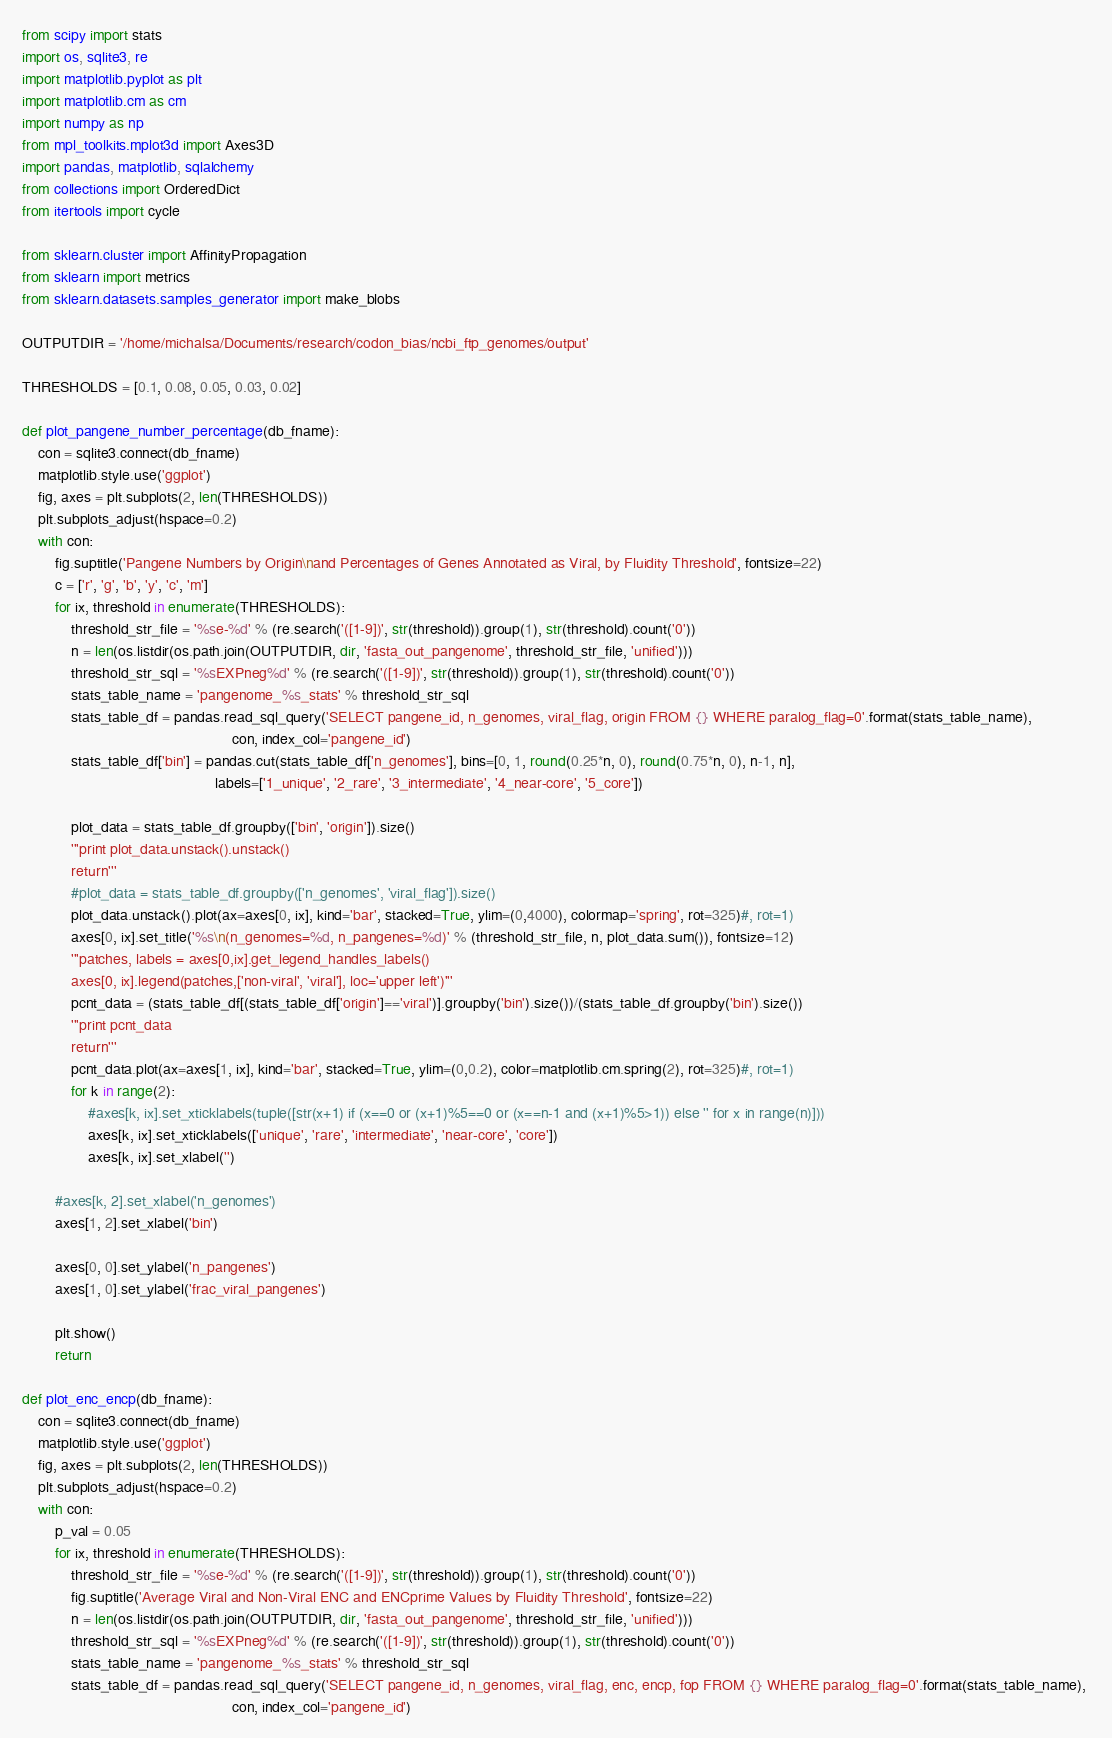Convert code to text. <code><loc_0><loc_0><loc_500><loc_500><_Python_>from scipy import stats
import os, sqlite3, re
import matplotlib.pyplot as plt
import matplotlib.cm as cm
import numpy as np
from mpl_toolkits.mplot3d import Axes3D
import pandas, matplotlib, sqlalchemy
from collections import OrderedDict
from itertools import cycle

from sklearn.cluster import AffinityPropagation
from sklearn import metrics
from sklearn.datasets.samples_generator import make_blobs

OUTPUTDIR = '/home/michalsa/Documents/research/codon_bias/ncbi_ftp_genomes/output'

THRESHOLDS = [0.1, 0.08, 0.05, 0.03, 0.02]

def plot_pangene_number_percentage(db_fname):
    con = sqlite3.connect(db_fname)
    matplotlib.style.use('ggplot')
    fig, axes = plt.subplots(2, len(THRESHOLDS))
    plt.subplots_adjust(hspace=0.2)
    with con:        
        fig.suptitle('Pangene Numbers by Origin\nand Percentages of Genes Annotated as Viral, by Fluidity Threshold', fontsize=22)
        c = ['r', 'g', 'b', 'y', 'c', 'm']
        for ix, threshold in enumerate(THRESHOLDS):
            threshold_str_file = '%se-%d' % (re.search('([1-9])', str(threshold)).group(1), str(threshold).count('0'))
            n = len(os.listdir(os.path.join(OUTPUTDIR, dir, 'fasta_out_pangenome', threshold_str_file, 'unified')))
            threshold_str_sql = '%sEXPneg%d' % (re.search('([1-9])', str(threshold)).group(1), str(threshold).count('0'))
            stats_table_name = 'pangenome_%s_stats' % threshold_str_sql
            stats_table_df = pandas.read_sql_query('SELECT pangene_id, n_genomes, viral_flag, origin FROM {} WHERE paralog_flag=0'.format(stats_table_name), 
                                                   con, index_col='pangene_id')
            stats_table_df['bin'] = pandas.cut(stats_table_df['n_genomes'], bins=[0, 1, round(0.25*n, 0), round(0.75*n, 0), n-1, n], 
                                               labels=['1_unique', '2_rare', '3_intermediate', '4_near-core', '5_core'])
            
            plot_data = stats_table_df.groupby(['bin', 'origin']).size()
            '''print plot_data.unstack().unstack()
            return'''
            #plot_data = stats_table_df.groupby(['n_genomes', 'viral_flag']).size()
            plot_data.unstack().plot(ax=axes[0, ix], kind='bar', stacked=True, ylim=(0,4000), colormap='spring', rot=325)#, rot=1)
            axes[0, ix].set_title('%s\n(n_genomes=%d, n_pangenes=%d)' % (threshold_str_file, n, plot_data.sum()), fontsize=12)
            '''patches, labels = axes[0,ix].get_legend_handles_labels()
            axes[0, ix].legend(patches,['non-viral', 'viral'], loc='upper left')'''
            pcnt_data = (stats_table_df[(stats_table_df['origin']=='viral')].groupby('bin').size())/(stats_table_df.groupby('bin').size())
            '''print pcnt_data
            return'''
            pcnt_data.plot(ax=axes[1, ix], kind='bar', stacked=True, ylim=(0,0.2), color=matplotlib.cm.spring(2), rot=325)#, rot=1)
            for k in range(2):
                #axes[k, ix].set_xticklabels(tuple([str(x+1) if (x==0 or (x+1)%5==0 or (x==n-1 and (x+1)%5>1)) else '' for x in range(n)]))
                axes[k, ix].set_xticklabels(['unique', 'rare', 'intermediate', 'near-core', 'core'])
                axes[k, ix].set_xlabel('')
        
        #axes[k, 2].set_xlabel('n_genomes')
        axes[1, 2].set_xlabel('bin')
        
        axes[0, 0].set_ylabel('n_pangenes')
        axes[1, 0].set_ylabel('frac_viral_pangenes')
        
        plt.show()
        return

def plot_enc_encp(db_fname):
    con = sqlite3.connect(db_fname)
    matplotlib.style.use('ggplot')
    fig, axes = plt.subplots(2, len(THRESHOLDS))
    plt.subplots_adjust(hspace=0.2)
    with con:
        p_val = 0.05
        for ix, threshold in enumerate(THRESHOLDS):
            threshold_str_file = '%se-%d' % (re.search('([1-9])', str(threshold)).group(1), str(threshold).count('0'))
            fig.suptitle('Average Viral and Non-Viral ENC and ENCprime Values by Fluidity Threshold', fontsize=22)
            n = len(os.listdir(os.path.join(OUTPUTDIR, dir, 'fasta_out_pangenome', threshold_str_file, 'unified')))
            threshold_str_sql = '%sEXPneg%d' % (re.search('([1-9])', str(threshold)).group(1), str(threshold).count('0'))
            stats_table_name = 'pangenome_%s_stats' % threshold_str_sql
            stats_table_df = pandas.read_sql_query('SELECT pangene_id, n_genomes, viral_flag, enc, encp, fop FROM {} WHERE paralog_flag=0'.format(stats_table_name), 
                                                   con, index_col='pangene_id')</code> 